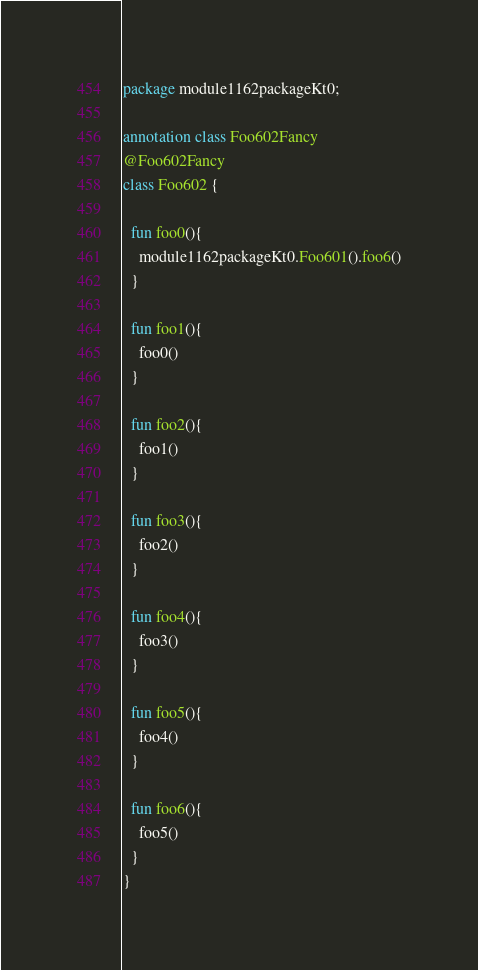<code> <loc_0><loc_0><loc_500><loc_500><_Kotlin_>package module1162packageKt0;

annotation class Foo602Fancy
@Foo602Fancy
class Foo602 {

  fun foo0(){
    module1162packageKt0.Foo601().foo6()
  }

  fun foo1(){
    foo0()
  }

  fun foo2(){
    foo1()
  }

  fun foo3(){
    foo2()
  }

  fun foo4(){
    foo3()
  }

  fun foo5(){
    foo4()
  }

  fun foo6(){
    foo5()
  }
}</code> 